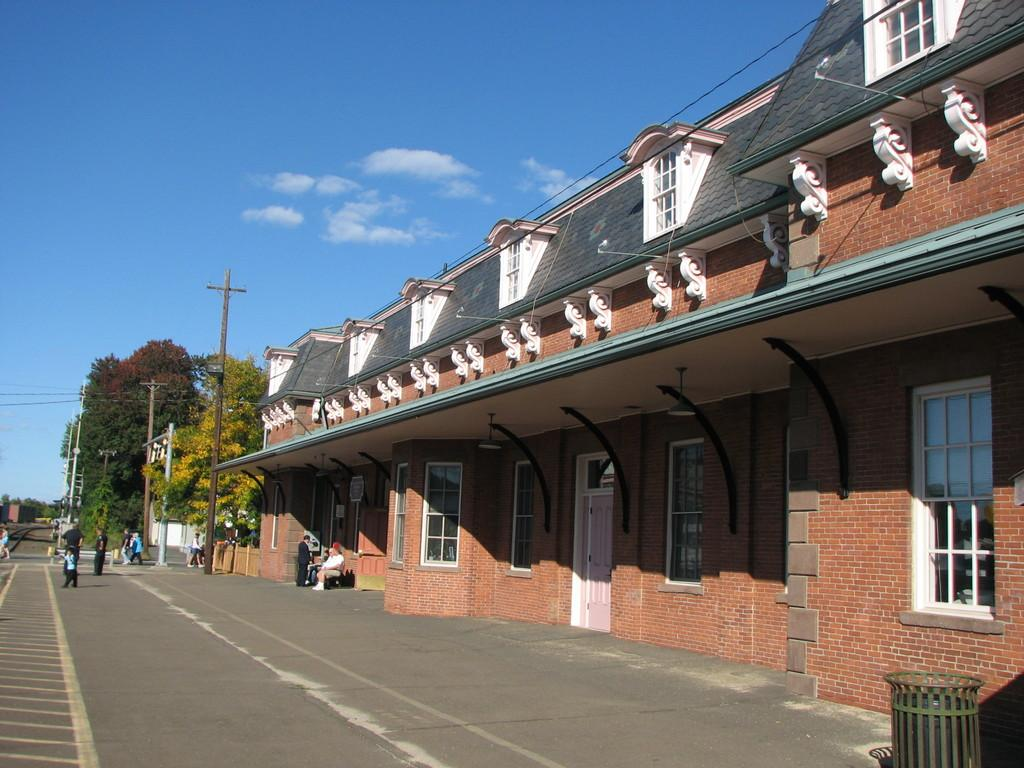How many people are in the image? There is a group of people standing in the image, but the exact number cannot be determined from the provided facts. What is the person on the bench doing? The person sitting on the bench is not described in the provided facts, so their activity cannot be determined. What type of structure is visible in the image? There is a building in the image. What type of pathway is present in the image? There is a road in the image. What type of vertical structures are present in the image? There are poles in the image. What type of vegetation is present in the image? There are trees in the image. What part of the natural environment is visible in the image? The sky is visible in the image. How many legs does the sand have in the image? There is no sand present in the image, so the number of legs cannot be determined. 